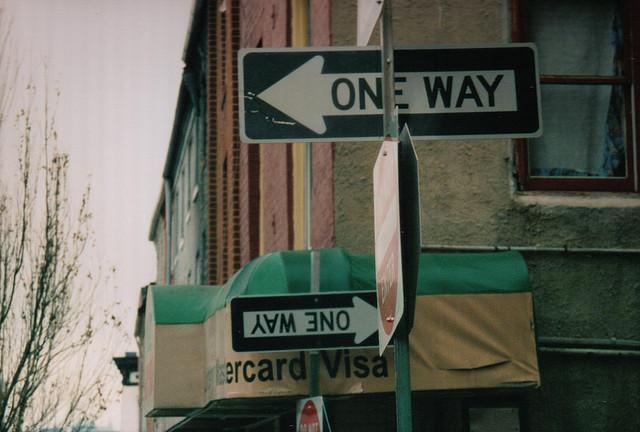Is this sign stating that it is in United States?
Quick response, please. No. What traffic sign does the poster resemble?
Give a very brief answer. One way. What language are the signs written in?
Write a very short answer. English. Which sign is upside down?
Be succinct. One way. What do both of these signs say?
Short answer required. One way. 